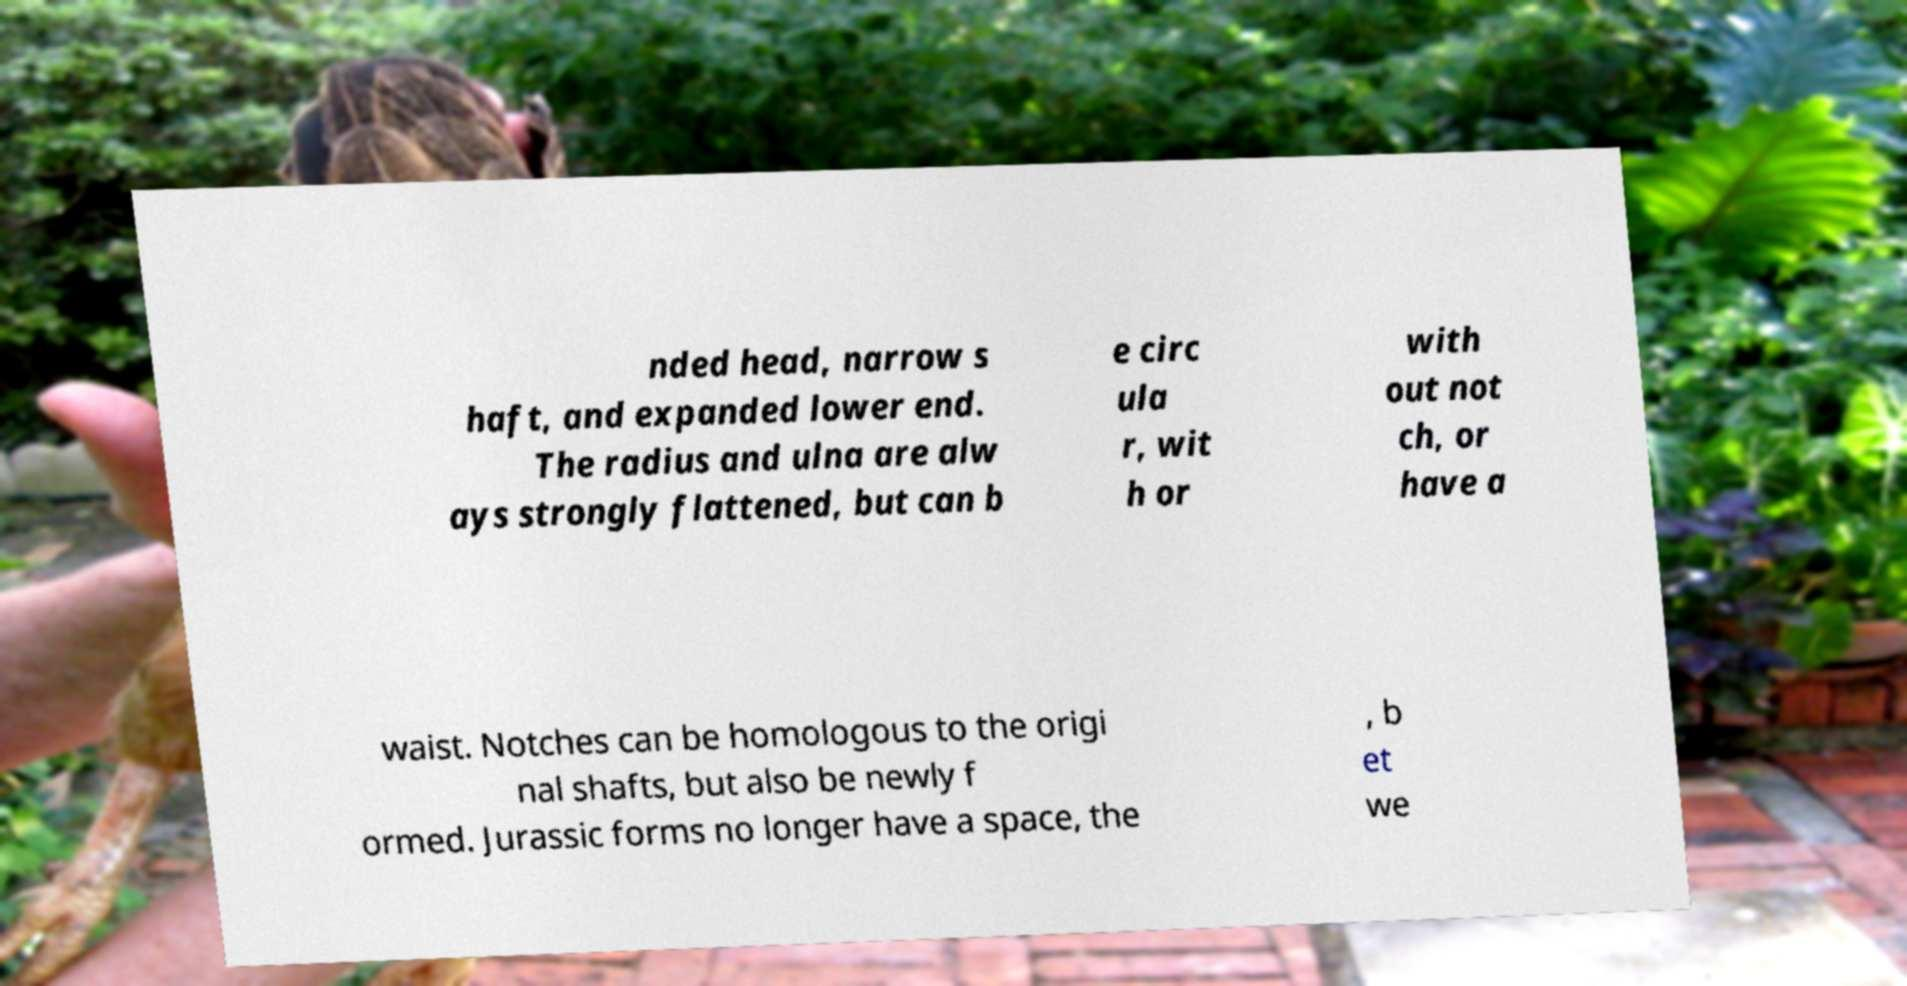For documentation purposes, I need the text within this image transcribed. Could you provide that? nded head, narrow s haft, and expanded lower end. The radius and ulna are alw ays strongly flattened, but can b e circ ula r, wit h or with out not ch, or have a waist. Notches can be homologous to the origi nal shafts, but also be newly f ormed. Jurassic forms no longer have a space, the , b et we 